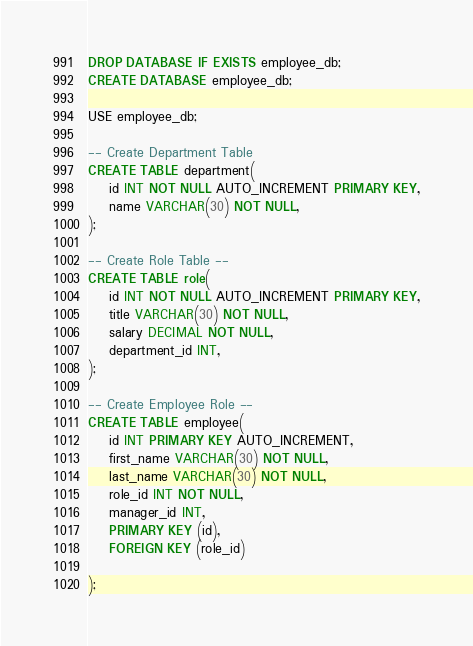Convert code to text. <code><loc_0><loc_0><loc_500><loc_500><_SQL_>DROP DATABASE IF EXISTS employee_db;
CREATE DATABASE employee_db;

USE employee_db;

-- Create Department Table
CREATE TABLE department(
    id INT NOT NULL AUTO_INCREMENT PRIMARY KEY,
    name VARCHAR(30) NOT NULL,
);

-- Create Role Table --
CREATE TABLE role(
    id INT NOT NULL AUTO_INCREMENT PRIMARY KEY,
    title VARCHAR(30) NOT NULL,
    salary DECIMAL NOT NULL,
    department_id INT,
);

-- Create Employee Role --
CREATE TABLE employee(
    id INT PRIMARY KEY AUTO_INCREMENT,
    first_name VARCHAR(30) NOT NULL,
    last_name VARCHAR(30) NOT NULL,
    role_id INT NOT NULL,
    manager_id INT,
    PRIMARY KEY (id),
    FOREIGN KEY (role_id)
    
);</code> 